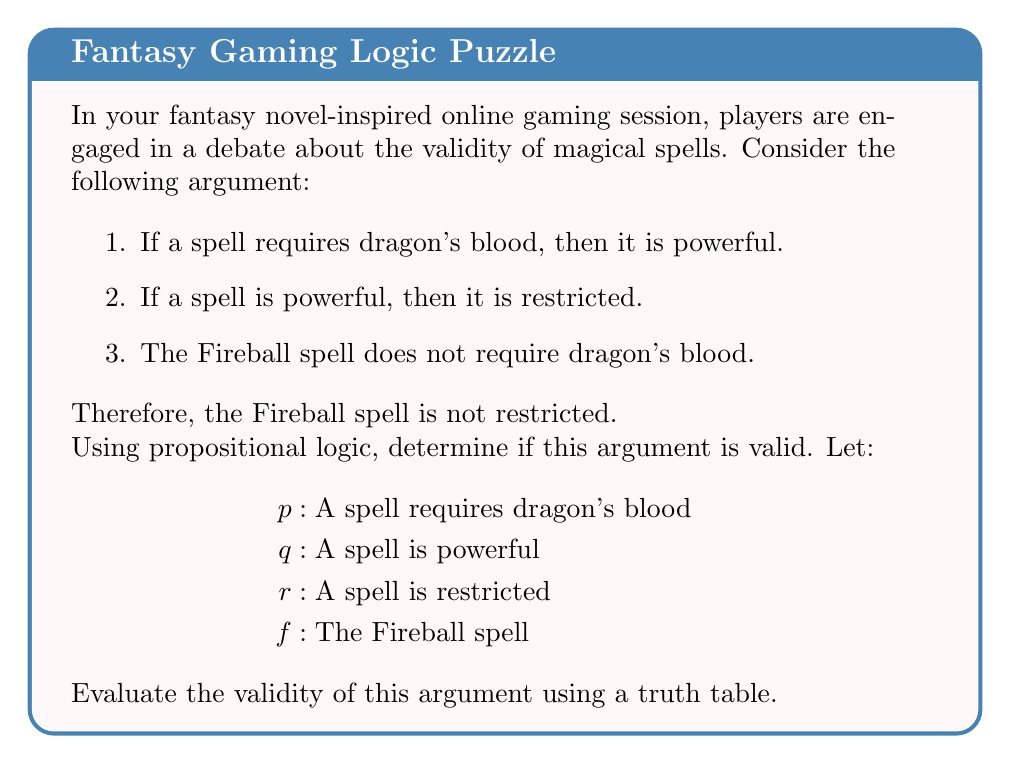Help me with this question. To evaluate the validity of this argument, we'll follow these steps:

1. Translate the premises and conclusion into symbolic form:
   Premise 1: $p \rightarrow q$
   Premise 2: $q \rightarrow r$
   Premise 3: $\neg p_f$ (where $p_f$ means "Fireball requires dragon's blood")
   Conclusion: $\neg r_f$ (where $r_f$ means "Fireball is restricted")

2. The argument form is:
   $$(p \rightarrow q) \land (q \rightarrow r) \land \neg p_f \therefore \neg r_f$$

3. To check validity, we need to ensure that whenever all premises are true, the conclusion is also true. We'll construct a truth table:

   $$\begin{array}{cccc|ccc|c}
   p & q & r & f & p \rightarrow q & q \rightarrow r & \neg p_f & \neg r_f \\
   \hline
   T & T & T & T & T & T & F & F \\
   T & T & T & F & T & T & T & F \\
   T & T & F & T & T & F & F & T \\
   T & T & F & F & T & F & T & T \\
   T & F & T & T & F & T & F & F \\
   T & F & T & F & F & T & T & F \\
   T & F & F & T & F & T & F & T \\
   T & F & F & F & F & T & T & T \\
   F & T & T & T & T & T & T & F \\
   F & T & T & F & T & T & T & F \\
   F & T & F & T & T & F & T & T \\
   F & T & F & F & T & F & T & T \\
   F & F & T & T & T & T & T & F \\
   F & F & T & F & T & T & T & F \\
   F & F & F & T & T & T & T & T \\
   F & F & F & F & T & T & T & T \\
   \end{array}$$

4. We need to find rows where all premises are true (highlighted in bold):

   $$\begin{array}{cccc|ccc|c}
   p & q & r & f & p \rightarrow q & q \rightarrow r & \neg p_f & \neg r_f \\
   \hline
   F & T & T & T & T & T & \mathbf{T} & F \\
   F & T & T & F & T & T & \mathbf{T} & F \\
   F & F & T & T & T & T & \mathbf{T} & F \\
   F & F & T & F & T & T & \mathbf{T} & F \\
   F & F & F & T & T & T & \mathbf{T} & \mathbf{T} \\
   F & F & F & F & T & T & \mathbf{T} & \mathbf{T} \\
   \end{array}$$

5. In the rows where all premises are true, we see that the conclusion is not always true. There are cases where $\neg r_f$ is false while all premises are true.

Therefore, the argument is not valid. The premises do not guarantee the truth of the conclusion.
Answer: Invalid argument 